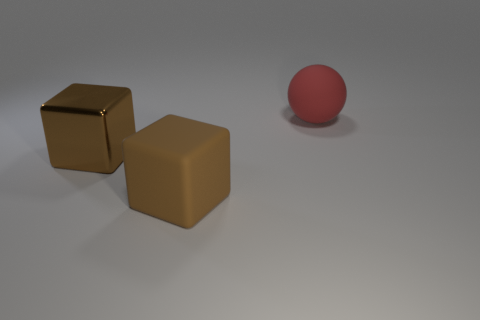How many other objects are there of the same color as the large shiny thing?
Your answer should be compact. 1. Does the red object have the same material as the brown block that is in front of the large shiny block?
Offer a terse response. Yes. How many large cubes are to the left of the large brown thing that is behind the big brown thing that is in front of the large shiny thing?
Ensure brevity in your answer.  0. Are there fewer large red matte balls in front of the large metallic thing than red objects right of the red sphere?
Make the answer very short. No. What number of other things are made of the same material as the ball?
Keep it short and to the point. 1. There is a brown thing that is the same size as the brown shiny block; what is it made of?
Ensure brevity in your answer.  Rubber. What number of green things are spheres or metal blocks?
Give a very brief answer. 0. There is a thing that is to the left of the red thing and right of the brown metallic block; what is its color?
Provide a short and direct response. Brown. Do the brown thing that is behind the big brown rubber thing and the big brown object in front of the brown shiny thing have the same material?
Keep it short and to the point. No. Are there more red rubber balls in front of the red matte ball than big red rubber spheres that are in front of the big brown matte object?
Make the answer very short. No. 